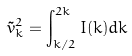<formula> <loc_0><loc_0><loc_500><loc_500>\tilde { v } _ { k } ^ { 2 } = \int _ { k / 2 } ^ { 2 k } I ( k ) d k</formula> 